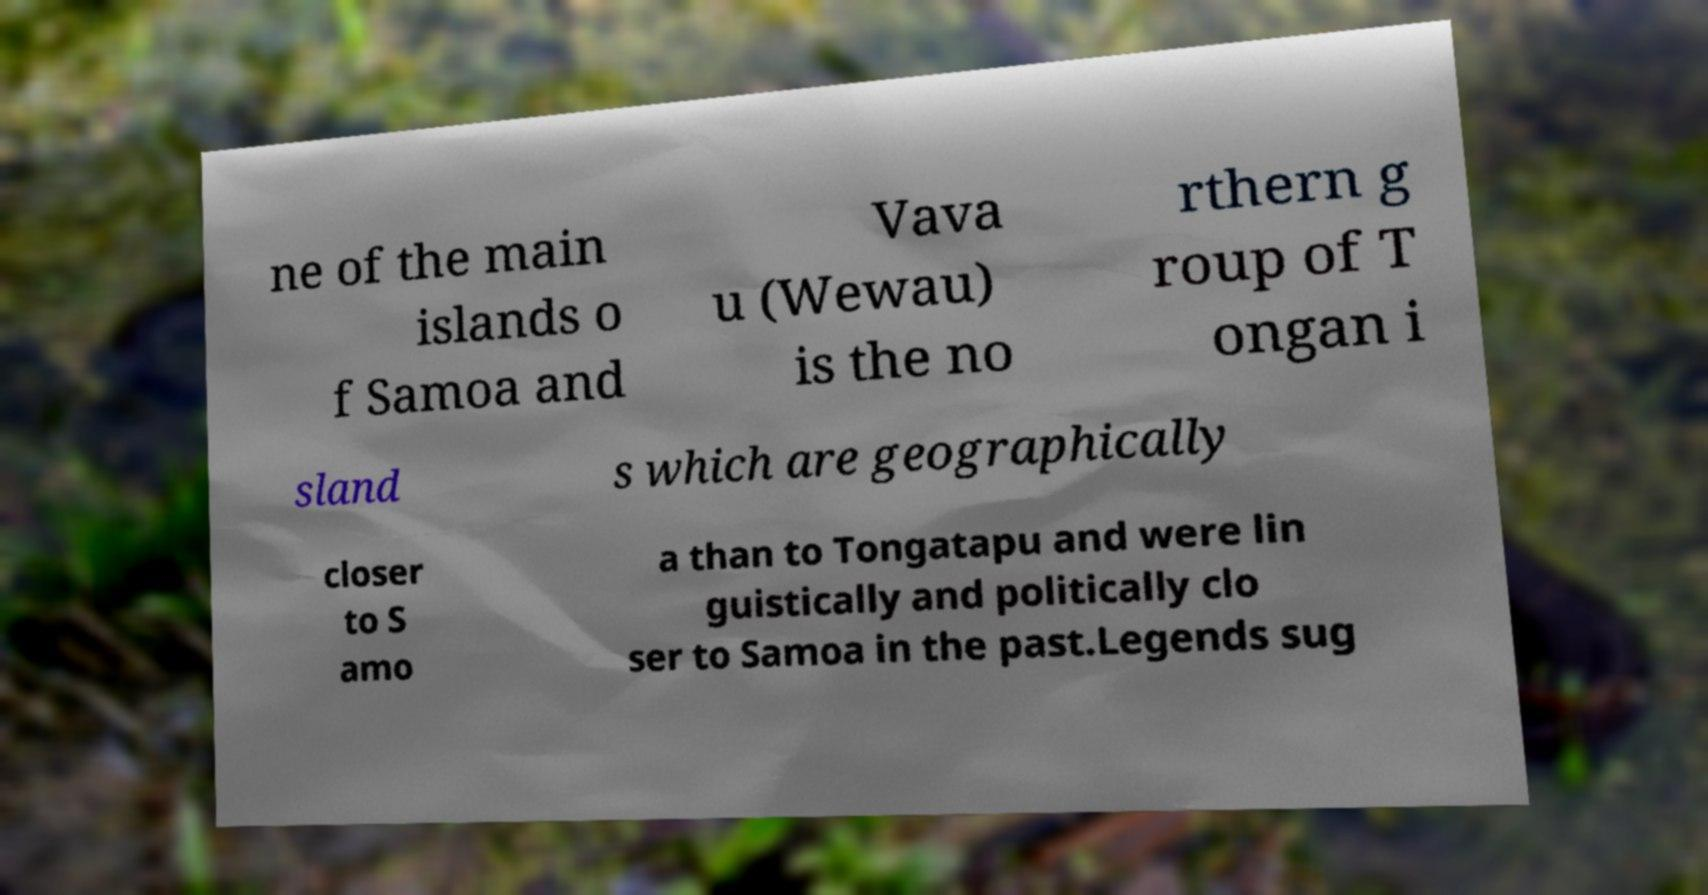Could you assist in decoding the text presented in this image and type it out clearly? ne of the main islands o f Samoa and Vava u (Wewau) is the no rthern g roup of T ongan i sland s which are geographically closer to S amo a than to Tongatapu and were lin guistically and politically clo ser to Samoa in the past.Legends sug 